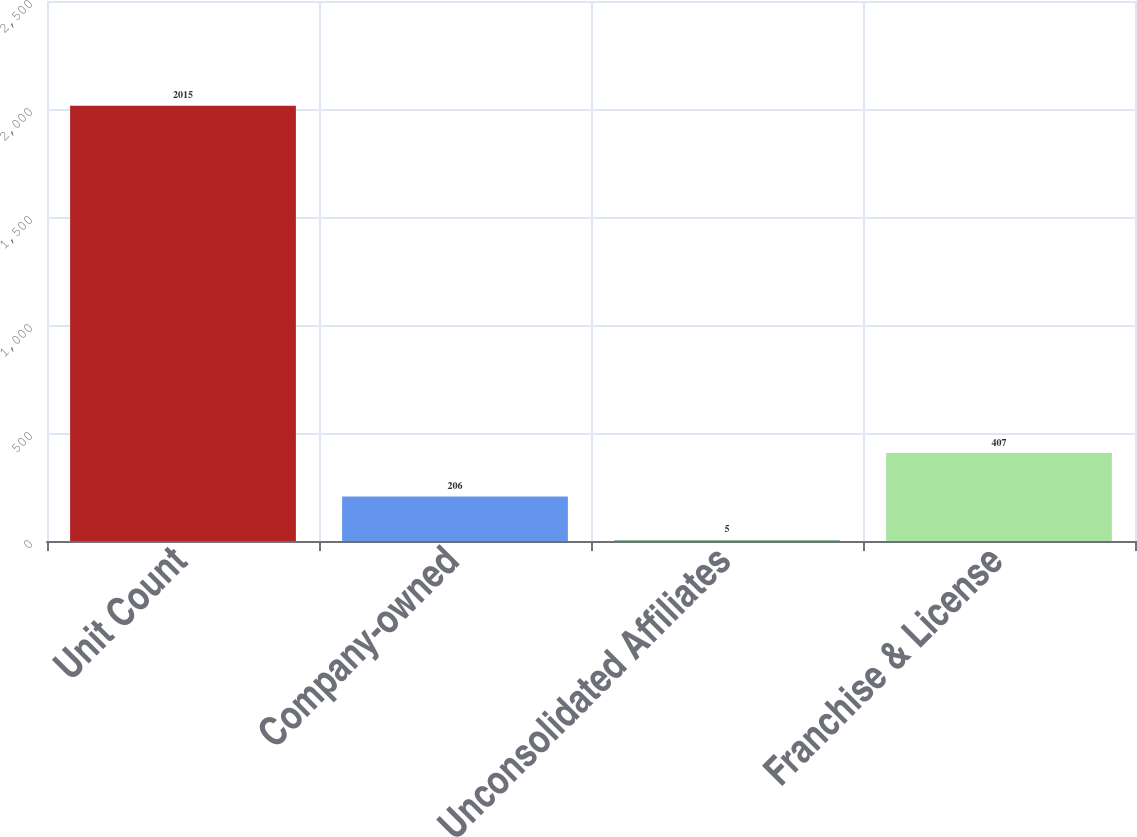<chart> <loc_0><loc_0><loc_500><loc_500><bar_chart><fcel>Unit Count<fcel>Company-owned<fcel>Unconsolidated Affiliates<fcel>Franchise & License<nl><fcel>2015<fcel>206<fcel>5<fcel>407<nl></chart> 